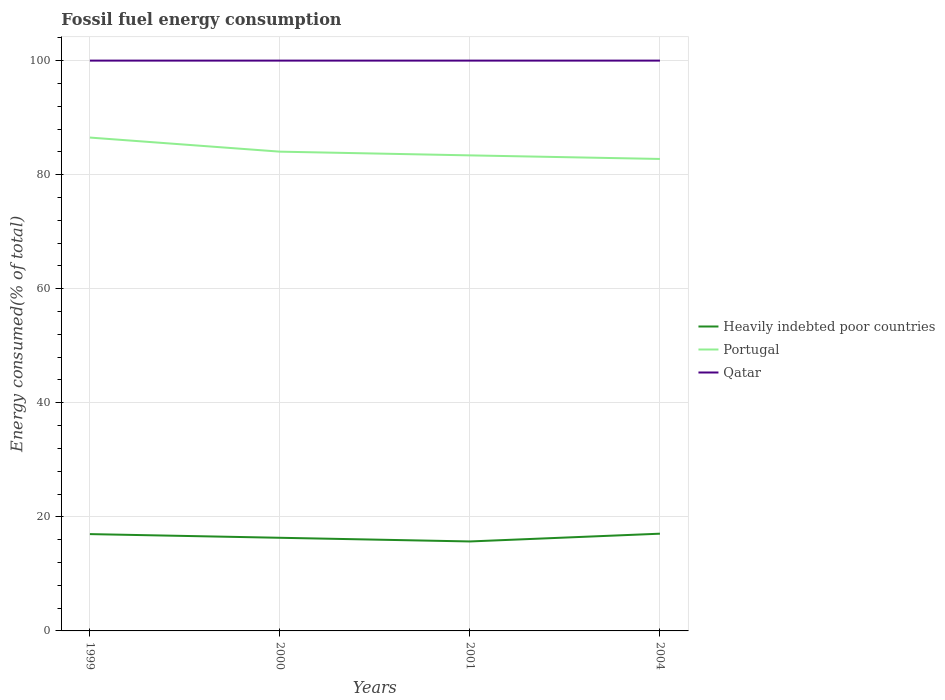How many different coloured lines are there?
Your response must be concise. 3. Is the number of lines equal to the number of legend labels?
Your response must be concise. Yes. Across all years, what is the maximum percentage of energy consumed in Portugal?
Your response must be concise. 82.76. What is the total percentage of energy consumed in Portugal in the graph?
Keep it short and to the point. 3.12. What is the difference between the highest and the second highest percentage of energy consumed in Qatar?
Ensure brevity in your answer.  9.157250900670988e-6. How many years are there in the graph?
Keep it short and to the point. 4. What is the difference between two consecutive major ticks on the Y-axis?
Keep it short and to the point. 20. How are the legend labels stacked?
Make the answer very short. Vertical. What is the title of the graph?
Give a very brief answer. Fossil fuel energy consumption. Does "High income: OECD" appear as one of the legend labels in the graph?
Offer a terse response. No. What is the label or title of the Y-axis?
Your answer should be very brief. Energy consumed(% of total). What is the Energy consumed(% of total) of Heavily indebted poor countries in 1999?
Make the answer very short. 16.98. What is the Energy consumed(% of total) in Portugal in 1999?
Provide a short and direct response. 86.51. What is the Energy consumed(% of total) in Qatar in 1999?
Your answer should be very brief. 100. What is the Energy consumed(% of total) of Heavily indebted poor countries in 2000?
Offer a very short reply. 16.33. What is the Energy consumed(% of total) in Portugal in 2000?
Offer a terse response. 84.04. What is the Energy consumed(% of total) of Qatar in 2000?
Your answer should be very brief. 100. What is the Energy consumed(% of total) in Heavily indebted poor countries in 2001?
Ensure brevity in your answer.  15.69. What is the Energy consumed(% of total) of Portugal in 2001?
Your answer should be compact. 83.39. What is the Energy consumed(% of total) of Qatar in 2001?
Make the answer very short. 100. What is the Energy consumed(% of total) in Heavily indebted poor countries in 2004?
Your answer should be very brief. 17.05. What is the Energy consumed(% of total) in Portugal in 2004?
Ensure brevity in your answer.  82.76. Across all years, what is the maximum Energy consumed(% of total) of Heavily indebted poor countries?
Provide a succinct answer. 17.05. Across all years, what is the maximum Energy consumed(% of total) in Portugal?
Keep it short and to the point. 86.51. Across all years, what is the minimum Energy consumed(% of total) in Heavily indebted poor countries?
Offer a terse response. 15.69. Across all years, what is the minimum Energy consumed(% of total) of Portugal?
Provide a succinct answer. 82.76. Across all years, what is the minimum Energy consumed(% of total) of Qatar?
Your answer should be compact. 100. What is the total Energy consumed(% of total) of Heavily indebted poor countries in the graph?
Offer a terse response. 66.05. What is the total Energy consumed(% of total) in Portugal in the graph?
Make the answer very short. 336.68. What is the total Energy consumed(% of total) of Qatar in the graph?
Offer a terse response. 400. What is the difference between the Energy consumed(% of total) in Heavily indebted poor countries in 1999 and that in 2000?
Offer a terse response. 0.65. What is the difference between the Energy consumed(% of total) of Portugal in 1999 and that in 2000?
Offer a very short reply. 2.47. What is the difference between the Energy consumed(% of total) in Qatar in 1999 and that in 2000?
Your answer should be very brief. 0. What is the difference between the Energy consumed(% of total) in Heavily indebted poor countries in 1999 and that in 2001?
Your answer should be compact. 1.29. What is the difference between the Energy consumed(% of total) in Portugal in 1999 and that in 2001?
Ensure brevity in your answer.  3.12. What is the difference between the Energy consumed(% of total) of Heavily indebted poor countries in 1999 and that in 2004?
Offer a terse response. -0.07. What is the difference between the Energy consumed(% of total) in Portugal in 1999 and that in 2004?
Provide a short and direct response. 3.75. What is the difference between the Energy consumed(% of total) of Heavily indebted poor countries in 2000 and that in 2001?
Keep it short and to the point. 0.64. What is the difference between the Energy consumed(% of total) in Portugal in 2000 and that in 2001?
Give a very brief answer. 0.65. What is the difference between the Energy consumed(% of total) of Heavily indebted poor countries in 2000 and that in 2004?
Ensure brevity in your answer.  -0.72. What is the difference between the Energy consumed(% of total) of Portugal in 2000 and that in 2004?
Provide a succinct answer. 1.28. What is the difference between the Energy consumed(% of total) in Qatar in 2000 and that in 2004?
Offer a terse response. -0. What is the difference between the Energy consumed(% of total) of Heavily indebted poor countries in 2001 and that in 2004?
Keep it short and to the point. -1.36. What is the difference between the Energy consumed(% of total) in Portugal in 2001 and that in 2004?
Offer a very short reply. 0.63. What is the difference between the Energy consumed(% of total) in Qatar in 2001 and that in 2004?
Make the answer very short. -0. What is the difference between the Energy consumed(% of total) of Heavily indebted poor countries in 1999 and the Energy consumed(% of total) of Portugal in 2000?
Offer a very short reply. -67.06. What is the difference between the Energy consumed(% of total) of Heavily indebted poor countries in 1999 and the Energy consumed(% of total) of Qatar in 2000?
Offer a terse response. -83.02. What is the difference between the Energy consumed(% of total) in Portugal in 1999 and the Energy consumed(% of total) in Qatar in 2000?
Make the answer very short. -13.49. What is the difference between the Energy consumed(% of total) of Heavily indebted poor countries in 1999 and the Energy consumed(% of total) of Portugal in 2001?
Offer a very short reply. -66.41. What is the difference between the Energy consumed(% of total) in Heavily indebted poor countries in 1999 and the Energy consumed(% of total) in Qatar in 2001?
Offer a terse response. -83.02. What is the difference between the Energy consumed(% of total) in Portugal in 1999 and the Energy consumed(% of total) in Qatar in 2001?
Keep it short and to the point. -13.49. What is the difference between the Energy consumed(% of total) of Heavily indebted poor countries in 1999 and the Energy consumed(% of total) of Portugal in 2004?
Give a very brief answer. -65.78. What is the difference between the Energy consumed(% of total) of Heavily indebted poor countries in 1999 and the Energy consumed(% of total) of Qatar in 2004?
Provide a short and direct response. -83.02. What is the difference between the Energy consumed(% of total) in Portugal in 1999 and the Energy consumed(% of total) in Qatar in 2004?
Your response must be concise. -13.49. What is the difference between the Energy consumed(% of total) in Heavily indebted poor countries in 2000 and the Energy consumed(% of total) in Portugal in 2001?
Ensure brevity in your answer.  -67.05. What is the difference between the Energy consumed(% of total) of Heavily indebted poor countries in 2000 and the Energy consumed(% of total) of Qatar in 2001?
Offer a terse response. -83.67. What is the difference between the Energy consumed(% of total) in Portugal in 2000 and the Energy consumed(% of total) in Qatar in 2001?
Make the answer very short. -15.96. What is the difference between the Energy consumed(% of total) of Heavily indebted poor countries in 2000 and the Energy consumed(% of total) of Portugal in 2004?
Provide a short and direct response. -66.43. What is the difference between the Energy consumed(% of total) in Heavily indebted poor countries in 2000 and the Energy consumed(% of total) in Qatar in 2004?
Provide a short and direct response. -83.67. What is the difference between the Energy consumed(% of total) of Portugal in 2000 and the Energy consumed(% of total) of Qatar in 2004?
Make the answer very short. -15.96. What is the difference between the Energy consumed(% of total) of Heavily indebted poor countries in 2001 and the Energy consumed(% of total) of Portugal in 2004?
Offer a terse response. -67.07. What is the difference between the Energy consumed(% of total) in Heavily indebted poor countries in 2001 and the Energy consumed(% of total) in Qatar in 2004?
Your answer should be very brief. -84.31. What is the difference between the Energy consumed(% of total) in Portugal in 2001 and the Energy consumed(% of total) in Qatar in 2004?
Provide a succinct answer. -16.61. What is the average Energy consumed(% of total) in Heavily indebted poor countries per year?
Provide a short and direct response. 16.51. What is the average Energy consumed(% of total) of Portugal per year?
Provide a short and direct response. 84.17. What is the average Energy consumed(% of total) in Qatar per year?
Provide a short and direct response. 100. In the year 1999, what is the difference between the Energy consumed(% of total) in Heavily indebted poor countries and Energy consumed(% of total) in Portugal?
Your answer should be very brief. -69.53. In the year 1999, what is the difference between the Energy consumed(% of total) of Heavily indebted poor countries and Energy consumed(% of total) of Qatar?
Offer a very short reply. -83.02. In the year 1999, what is the difference between the Energy consumed(% of total) of Portugal and Energy consumed(% of total) of Qatar?
Make the answer very short. -13.49. In the year 2000, what is the difference between the Energy consumed(% of total) of Heavily indebted poor countries and Energy consumed(% of total) of Portugal?
Your response must be concise. -67.71. In the year 2000, what is the difference between the Energy consumed(% of total) of Heavily indebted poor countries and Energy consumed(% of total) of Qatar?
Make the answer very short. -83.67. In the year 2000, what is the difference between the Energy consumed(% of total) in Portugal and Energy consumed(% of total) in Qatar?
Ensure brevity in your answer.  -15.96. In the year 2001, what is the difference between the Energy consumed(% of total) of Heavily indebted poor countries and Energy consumed(% of total) of Portugal?
Make the answer very short. -67.7. In the year 2001, what is the difference between the Energy consumed(% of total) in Heavily indebted poor countries and Energy consumed(% of total) in Qatar?
Provide a succinct answer. -84.31. In the year 2001, what is the difference between the Energy consumed(% of total) in Portugal and Energy consumed(% of total) in Qatar?
Provide a short and direct response. -16.61. In the year 2004, what is the difference between the Energy consumed(% of total) in Heavily indebted poor countries and Energy consumed(% of total) in Portugal?
Provide a succinct answer. -65.71. In the year 2004, what is the difference between the Energy consumed(% of total) of Heavily indebted poor countries and Energy consumed(% of total) of Qatar?
Provide a short and direct response. -82.95. In the year 2004, what is the difference between the Energy consumed(% of total) in Portugal and Energy consumed(% of total) in Qatar?
Offer a very short reply. -17.24. What is the ratio of the Energy consumed(% of total) in Heavily indebted poor countries in 1999 to that in 2000?
Provide a succinct answer. 1.04. What is the ratio of the Energy consumed(% of total) of Portugal in 1999 to that in 2000?
Give a very brief answer. 1.03. What is the ratio of the Energy consumed(% of total) of Qatar in 1999 to that in 2000?
Provide a short and direct response. 1. What is the ratio of the Energy consumed(% of total) of Heavily indebted poor countries in 1999 to that in 2001?
Give a very brief answer. 1.08. What is the ratio of the Energy consumed(% of total) in Portugal in 1999 to that in 2001?
Your answer should be very brief. 1.04. What is the ratio of the Energy consumed(% of total) of Qatar in 1999 to that in 2001?
Ensure brevity in your answer.  1. What is the ratio of the Energy consumed(% of total) of Heavily indebted poor countries in 1999 to that in 2004?
Keep it short and to the point. 1. What is the ratio of the Energy consumed(% of total) of Portugal in 1999 to that in 2004?
Offer a very short reply. 1.05. What is the ratio of the Energy consumed(% of total) in Qatar in 1999 to that in 2004?
Provide a succinct answer. 1. What is the ratio of the Energy consumed(% of total) in Heavily indebted poor countries in 2000 to that in 2001?
Offer a terse response. 1.04. What is the ratio of the Energy consumed(% of total) of Heavily indebted poor countries in 2000 to that in 2004?
Provide a short and direct response. 0.96. What is the ratio of the Energy consumed(% of total) in Portugal in 2000 to that in 2004?
Your answer should be compact. 1.02. What is the ratio of the Energy consumed(% of total) in Heavily indebted poor countries in 2001 to that in 2004?
Your answer should be compact. 0.92. What is the ratio of the Energy consumed(% of total) of Portugal in 2001 to that in 2004?
Your answer should be very brief. 1.01. What is the difference between the highest and the second highest Energy consumed(% of total) in Heavily indebted poor countries?
Your answer should be compact. 0.07. What is the difference between the highest and the second highest Energy consumed(% of total) in Portugal?
Offer a terse response. 2.47. What is the difference between the highest and the second highest Energy consumed(% of total) of Qatar?
Your answer should be very brief. 0. What is the difference between the highest and the lowest Energy consumed(% of total) of Heavily indebted poor countries?
Give a very brief answer. 1.36. What is the difference between the highest and the lowest Energy consumed(% of total) of Portugal?
Give a very brief answer. 3.75. 